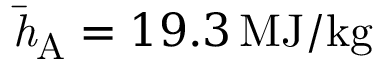<formula> <loc_0><loc_0><loc_500><loc_500>\bar { h } _ { A } = 1 9 . 3 \, M J / k g</formula> 